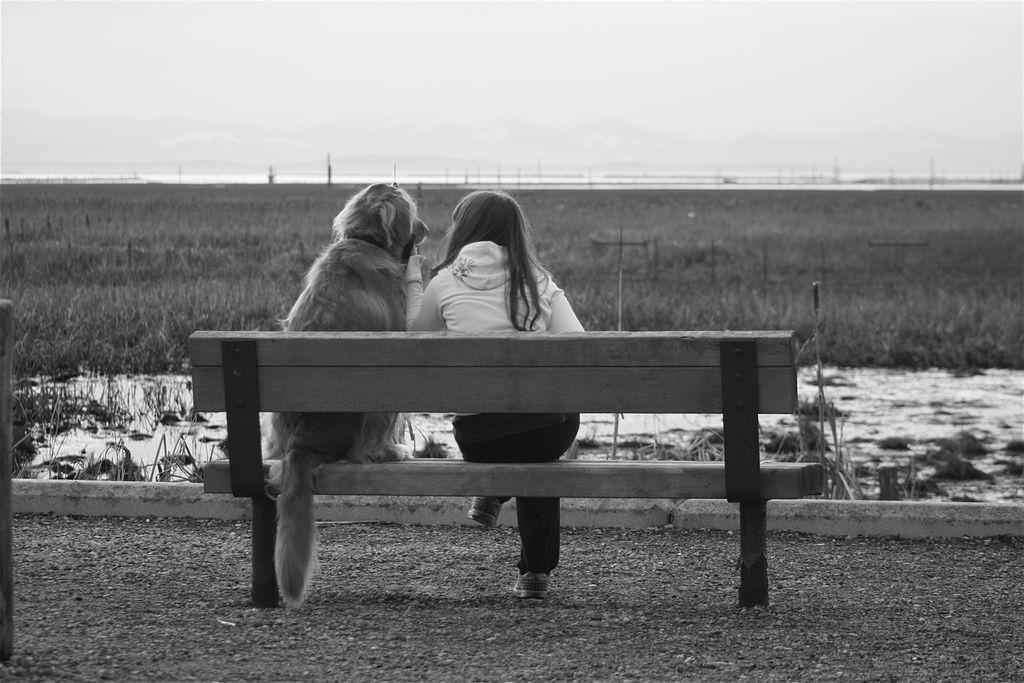In one or two sentences, can you explain what this image depicts? Black and white picture. On this bench this dog and this girl are sitting. 